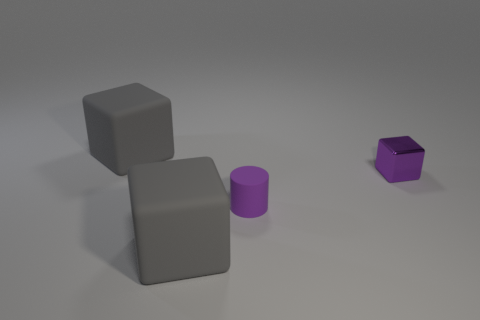There is a large gray matte thing that is behind the large gray cube in front of the small block; how many rubber cylinders are left of it?
Ensure brevity in your answer.  0. There is a purple object that is in front of the tiny purple metal thing; is its shape the same as the purple object to the right of the small rubber cylinder?
Provide a succinct answer. No. How many objects are matte cubes or cubes?
Keep it short and to the point. 3. There is a big gray object to the left of the gray matte cube that is in front of the purple shiny cube; what is its material?
Make the answer very short. Rubber. Is there a big rubber thing of the same color as the small block?
Your response must be concise. No. The metal cube that is the same size as the rubber cylinder is what color?
Provide a short and direct response. Purple. There is a gray cube to the left of the large gray cube that is in front of the big gray cube that is behind the small purple block; what is it made of?
Keep it short and to the point. Rubber. There is a small matte cylinder; is it the same color as the shiny object behind the tiny matte cylinder?
Make the answer very short. Yes. What number of things are large matte objects that are behind the tiny purple shiny block or gray rubber cubes behind the tiny purple cube?
Make the answer very short. 1. There is a gray thing in front of the large gray object that is behind the metallic cube; what is its shape?
Make the answer very short. Cube. 